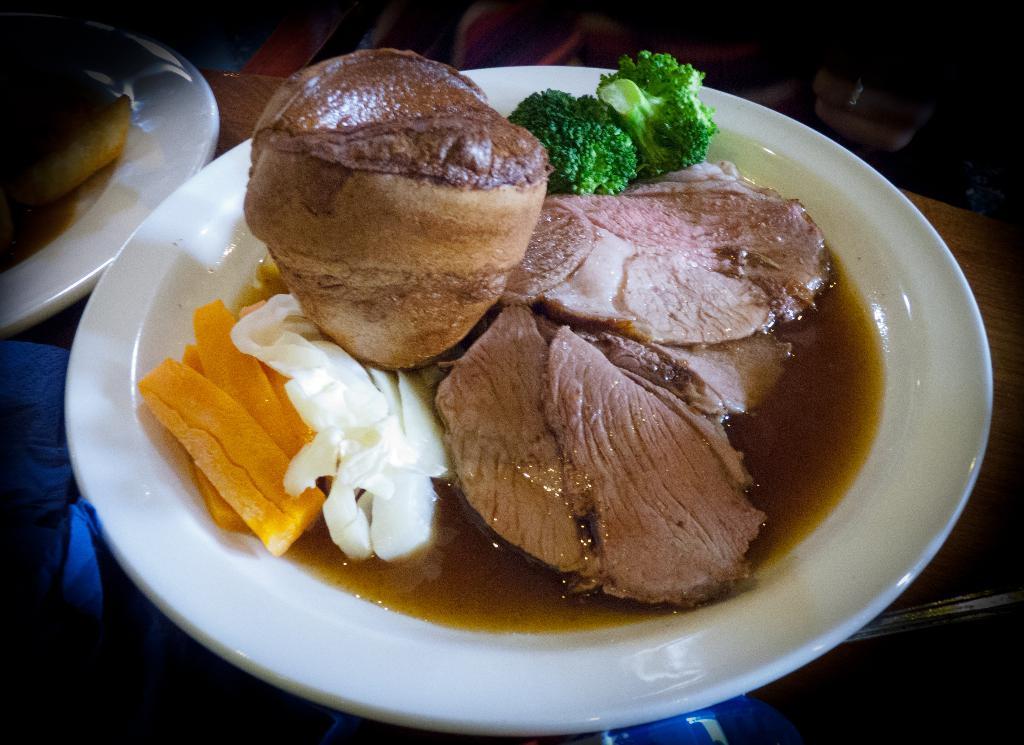Could you give a brief overview of what you see in this image? In this picture we can see plates with food and objects on the table. In the background of the image it is dark. 